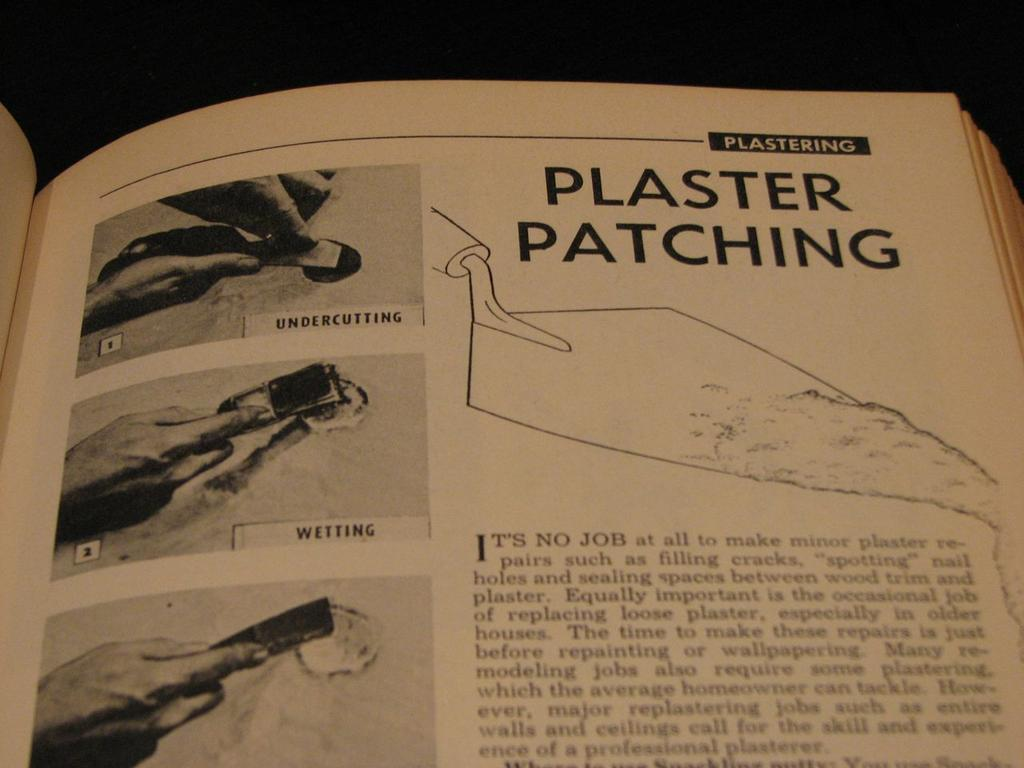<image>
Present a compact description of the photo's key features. A book is opened to a page that talks about plaster patching and has pictures. 